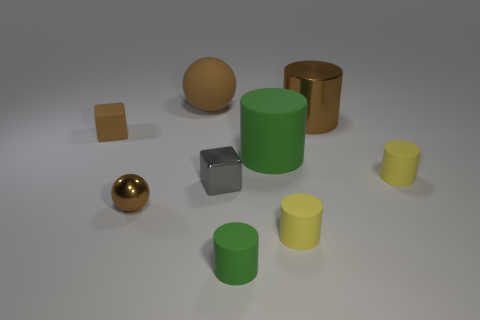Does the large ball have the same color as the tiny rubber cube?
Your response must be concise. Yes. How many objects are either things that are on the left side of the large sphere or large rubber cylinders that are on the right side of the tiny brown block?
Make the answer very short. 3. Is the number of tiny brown matte cubes left of the rubber block greater than the number of large green things that are behind the big metal object?
Offer a very short reply. No. What is the color of the ball behind the gray cube?
Your answer should be compact. Brown. Are there any green objects of the same shape as the small gray metal thing?
Provide a short and direct response. No. What number of brown things are large objects or blocks?
Your response must be concise. 3. Are there any green cylinders of the same size as the brown metallic cylinder?
Ensure brevity in your answer.  Yes. How many matte cylinders are there?
Give a very brief answer. 4. What number of large things are green rubber things or rubber cubes?
Give a very brief answer. 1. What is the color of the large matte object on the left side of the green object that is in front of the yellow rubber cylinder behind the brown metallic ball?
Keep it short and to the point. Brown. 